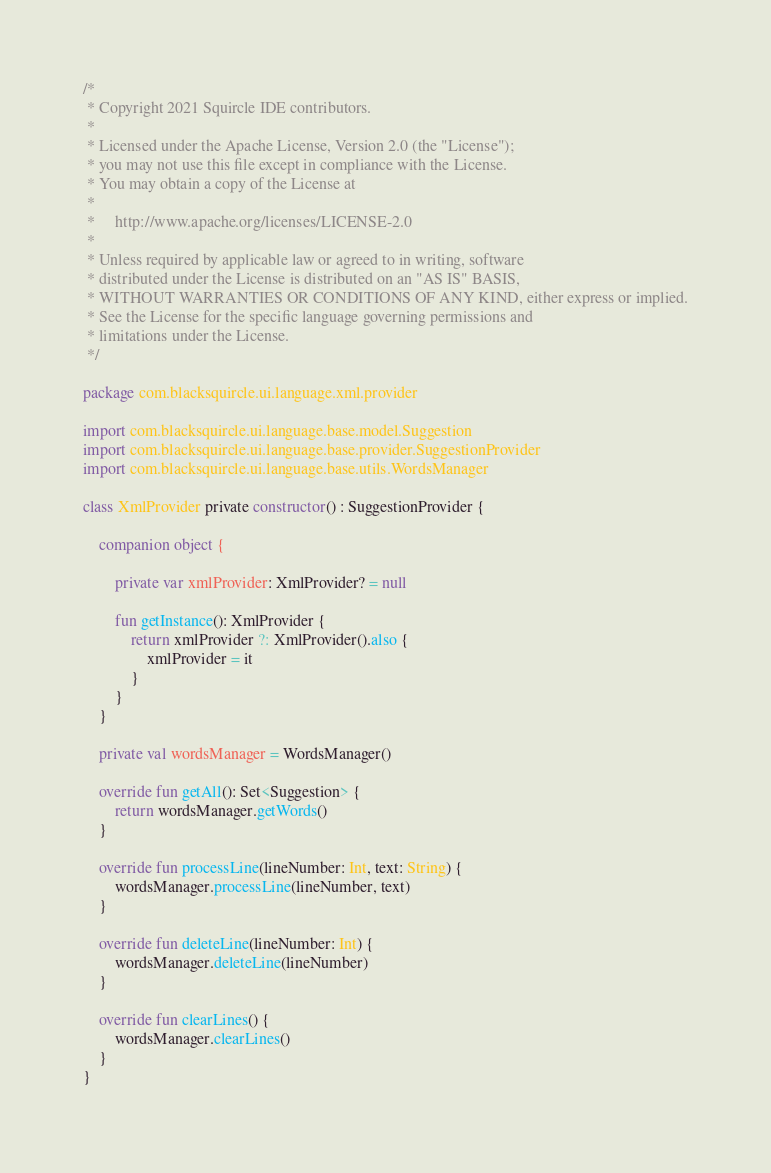Convert code to text. <code><loc_0><loc_0><loc_500><loc_500><_Kotlin_>/*
 * Copyright 2021 Squircle IDE contributors.
 *
 * Licensed under the Apache License, Version 2.0 (the "License");
 * you may not use this file except in compliance with the License.
 * You may obtain a copy of the License at
 *
 *     http://www.apache.org/licenses/LICENSE-2.0
 *
 * Unless required by applicable law or agreed to in writing, software
 * distributed under the License is distributed on an "AS IS" BASIS,
 * WITHOUT WARRANTIES OR CONDITIONS OF ANY KIND, either express or implied.
 * See the License for the specific language governing permissions and
 * limitations under the License.
 */

package com.blacksquircle.ui.language.xml.provider

import com.blacksquircle.ui.language.base.model.Suggestion
import com.blacksquircle.ui.language.base.provider.SuggestionProvider
import com.blacksquircle.ui.language.base.utils.WordsManager

class XmlProvider private constructor() : SuggestionProvider {

    companion object {

        private var xmlProvider: XmlProvider? = null

        fun getInstance(): XmlProvider {
            return xmlProvider ?: XmlProvider().also {
                xmlProvider = it
            }
        }
    }

    private val wordsManager = WordsManager()

    override fun getAll(): Set<Suggestion> {
        return wordsManager.getWords()
    }

    override fun processLine(lineNumber: Int, text: String) {
        wordsManager.processLine(lineNumber, text)
    }

    override fun deleteLine(lineNumber: Int) {
        wordsManager.deleteLine(lineNumber)
    }

    override fun clearLines() {
        wordsManager.clearLines()
    }
}</code> 